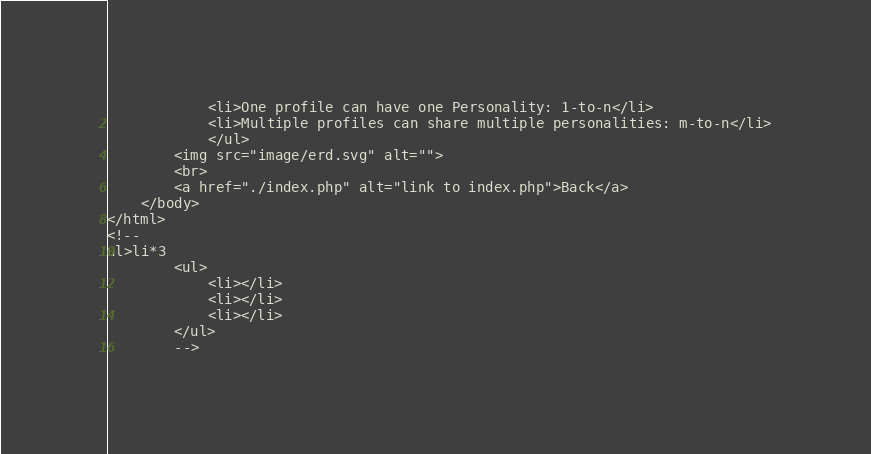<code> <loc_0><loc_0><loc_500><loc_500><_PHP_>			<li>One profile can have one Personality: 1-to-n</li>
			<li>Multiple profiles can share multiple personalities: m-to-n</li>
			</ul>
		<img src="image/erd.svg" alt="">
		<br>
		<a href="./index.php" alt="link to index.php">Back</a>
	</body>
</html>
<!--
ul>li*3
		<ul>
			<li></li>
			<li></li>
			<li></li>
		</ul>
		--></code> 